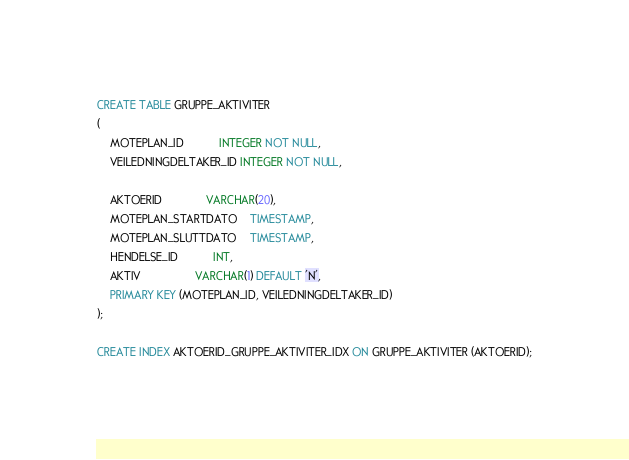<code> <loc_0><loc_0><loc_500><loc_500><_SQL_>CREATE TABLE GRUPPE_AKTIVITER
(
    MOTEPLAN_ID           INTEGER NOT NULL,
    VEILEDNINGDELTAKER_ID INTEGER NOT NULL,

    AKTOERID              VARCHAR(20),
    MOTEPLAN_STARTDATO    TIMESTAMP,
    MOTEPLAN_SLUTTDATO    TIMESTAMP,
    HENDELSE_ID           INT,
    AKTIV                 VARCHAR(1) DEFAULT 'N',
    PRIMARY KEY (MOTEPLAN_ID, VEILEDNINGDELTAKER_ID)
);

CREATE INDEX AKTOERID_GRUPPE_AKTIVITER_IDX ON GRUPPE_AKTIVITER (AKTOERID);</code> 